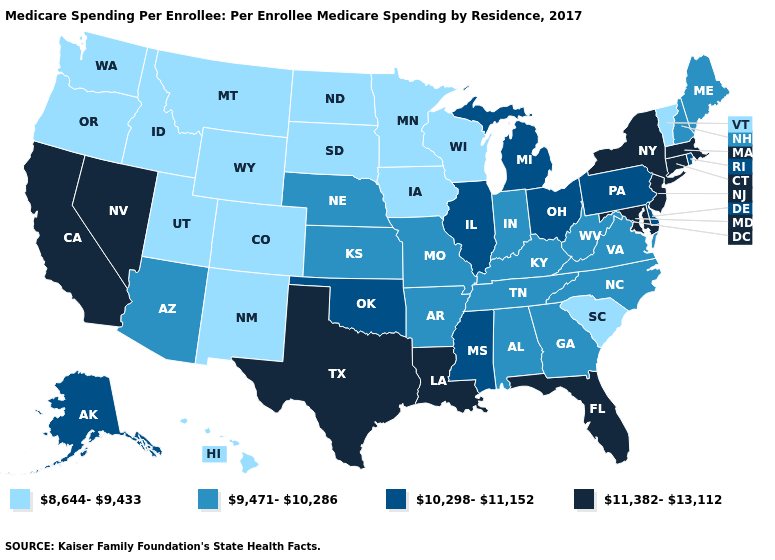What is the value of Hawaii?
Short answer required. 8,644-9,433. Among the states that border Vermont , which have the lowest value?
Answer briefly. New Hampshire. Name the states that have a value in the range 10,298-11,152?
Give a very brief answer. Alaska, Delaware, Illinois, Michigan, Mississippi, Ohio, Oklahoma, Pennsylvania, Rhode Island. What is the value of Michigan?
Keep it brief. 10,298-11,152. Name the states that have a value in the range 9,471-10,286?
Quick response, please. Alabama, Arizona, Arkansas, Georgia, Indiana, Kansas, Kentucky, Maine, Missouri, Nebraska, New Hampshire, North Carolina, Tennessee, Virginia, West Virginia. What is the value of Texas?
Give a very brief answer. 11,382-13,112. Among the states that border Colorado , does Utah have the highest value?
Keep it brief. No. Does South Carolina have the highest value in the USA?
Concise answer only. No. Does Pennsylvania have the same value as Michigan?
Write a very short answer. Yes. How many symbols are there in the legend?
Short answer required. 4. What is the value of Pennsylvania?
Quick response, please. 10,298-11,152. Does Maryland have the highest value in the USA?
Keep it brief. Yes. Name the states that have a value in the range 9,471-10,286?
Be succinct. Alabama, Arizona, Arkansas, Georgia, Indiana, Kansas, Kentucky, Maine, Missouri, Nebraska, New Hampshire, North Carolina, Tennessee, Virginia, West Virginia. Name the states that have a value in the range 9,471-10,286?
Quick response, please. Alabama, Arizona, Arkansas, Georgia, Indiana, Kansas, Kentucky, Maine, Missouri, Nebraska, New Hampshire, North Carolina, Tennessee, Virginia, West Virginia. What is the highest value in the West ?
Be succinct. 11,382-13,112. 